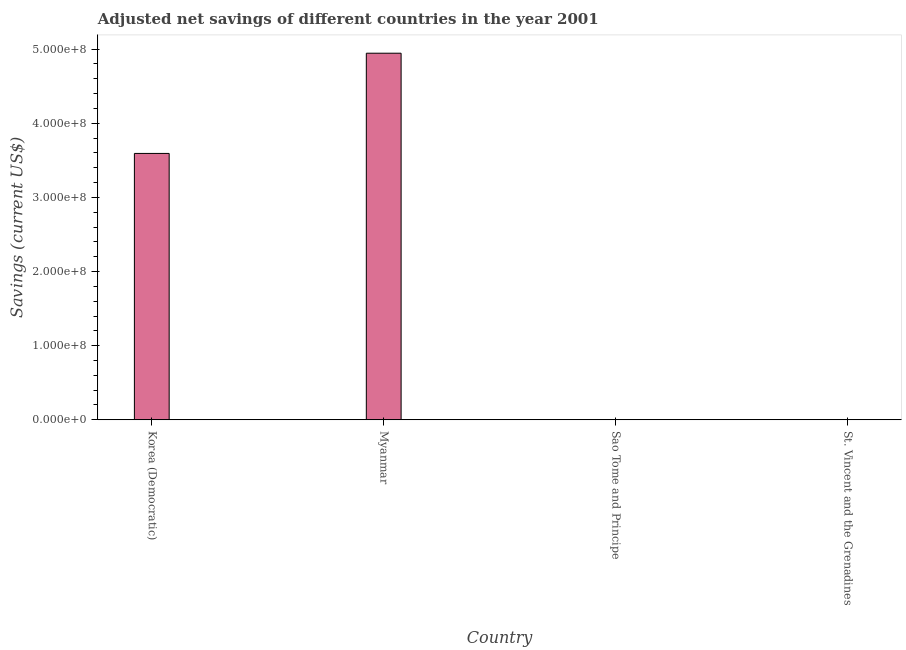Does the graph contain grids?
Provide a succinct answer. No. What is the title of the graph?
Keep it short and to the point. Adjusted net savings of different countries in the year 2001. What is the label or title of the X-axis?
Your answer should be compact. Country. What is the label or title of the Y-axis?
Give a very brief answer. Savings (current US$). What is the adjusted net savings in Myanmar?
Your answer should be compact. 4.95e+08. Across all countries, what is the maximum adjusted net savings?
Make the answer very short. 4.95e+08. Across all countries, what is the minimum adjusted net savings?
Provide a succinct answer. 5130.39. In which country was the adjusted net savings maximum?
Offer a terse response. Myanmar. In which country was the adjusted net savings minimum?
Offer a terse response. Sao Tome and Principe. What is the sum of the adjusted net savings?
Offer a terse response. 8.54e+08. What is the difference between the adjusted net savings in Korea (Democratic) and Sao Tome and Principe?
Offer a terse response. 3.59e+08. What is the average adjusted net savings per country?
Offer a very short reply. 2.13e+08. What is the median adjusted net savings?
Provide a succinct answer. 1.80e+08. What is the ratio of the adjusted net savings in Korea (Democratic) to that in St. Vincent and the Grenadines?
Your answer should be compact. 2754.1. Is the difference between the adjusted net savings in Myanmar and Sao Tome and Principe greater than the difference between any two countries?
Give a very brief answer. Yes. What is the difference between the highest and the second highest adjusted net savings?
Ensure brevity in your answer.  1.35e+08. What is the difference between the highest and the lowest adjusted net savings?
Offer a very short reply. 4.95e+08. How many bars are there?
Make the answer very short. 4. Are all the bars in the graph horizontal?
Provide a short and direct response. No. What is the difference between two consecutive major ticks on the Y-axis?
Your response must be concise. 1.00e+08. Are the values on the major ticks of Y-axis written in scientific E-notation?
Offer a very short reply. Yes. What is the Savings (current US$) in Korea (Democratic)?
Provide a succinct answer. 3.59e+08. What is the Savings (current US$) of Myanmar?
Give a very brief answer. 4.95e+08. What is the Savings (current US$) in Sao Tome and Principe?
Your response must be concise. 5130.39. What is the Savings (current US$) of St. Vincent and the Grenadines?
Your response must be concise. 1.30e+05. What is the difference between the Savings (current US$) in Korea (Democratic) and Myanmar?
Provide a succinct answer. -1.35e+08. What is the difference between the Savings (current US$) in Korea (Democratic) and Sao Tome and Principe?
Make the answer very short. 3.59e+08. What is the difference between the Savings (current US$) in Korea (Democratic) and St. Vincent and the Grenadines?
Provide a short and direct response. 3.59e+08. What is the difference between the Savings (current US$) in Myanmar and Sao Tome and Principe?
Provide a succinct answer. 4.95e+08. What is the difference between the Savings (current US$) in Myanmar and St. Vincent and the Grenadines?
Offer a terse response. 4.94e+08. What is the difference between the Savings (current US$) in Sao Tome and Principe and St. Vincent and the Grenadines?
Provide a succinct answer. -1.25e+05. What is the ratio of the Savings (current US$) in Korea (Democratic) to that in Myanmar?
Keep it short and to the point. 0.73. What is the ratio of the Savings (current US$) in Korea (Democratic) to that in Sao Tome and Principe?
Provide a short and direct response. 7.00e+04. What is the ratio of the Savings (current US$) in Korea (Democratic) to that in St. Vincent and the Grenadines?
Provide a short and direct response. 2754.1. What is the ratio of the Savings (current US$) in Myanmar to that in Sao Tome and Principe?
Make the answer very short. 9.64e+04. What is the ratio of the Savings (current US$) in Myanmar to that in St. Vincent and the Grenadines?
Provide a succinct answer. 3790.35. What is the ratio of the Savings (current US$) in Sao Tome and Principe to that in St. Vincent and the Grenadines?
Give a very brief answer. 0.04. 